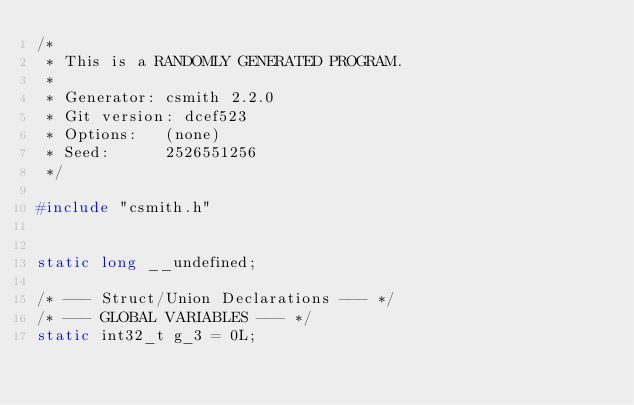<code> <loc_0><loc_0><loc_500><loc_500><_C_>/*
 * This is a RANDOMLY GENERATED PROGRAM.
 *
 * Generator: csmith 2.2.0
 * Git version: dcef523
 * Options:   (none)
 * Seed:      2526551256
 */

#include "csmith.h"


static long __undefined;

/* --- Struct/Union Declarations --- */
/* --- GLOBAL VARIABLES --- */
static int32_t g_3 = 0L;</code> 